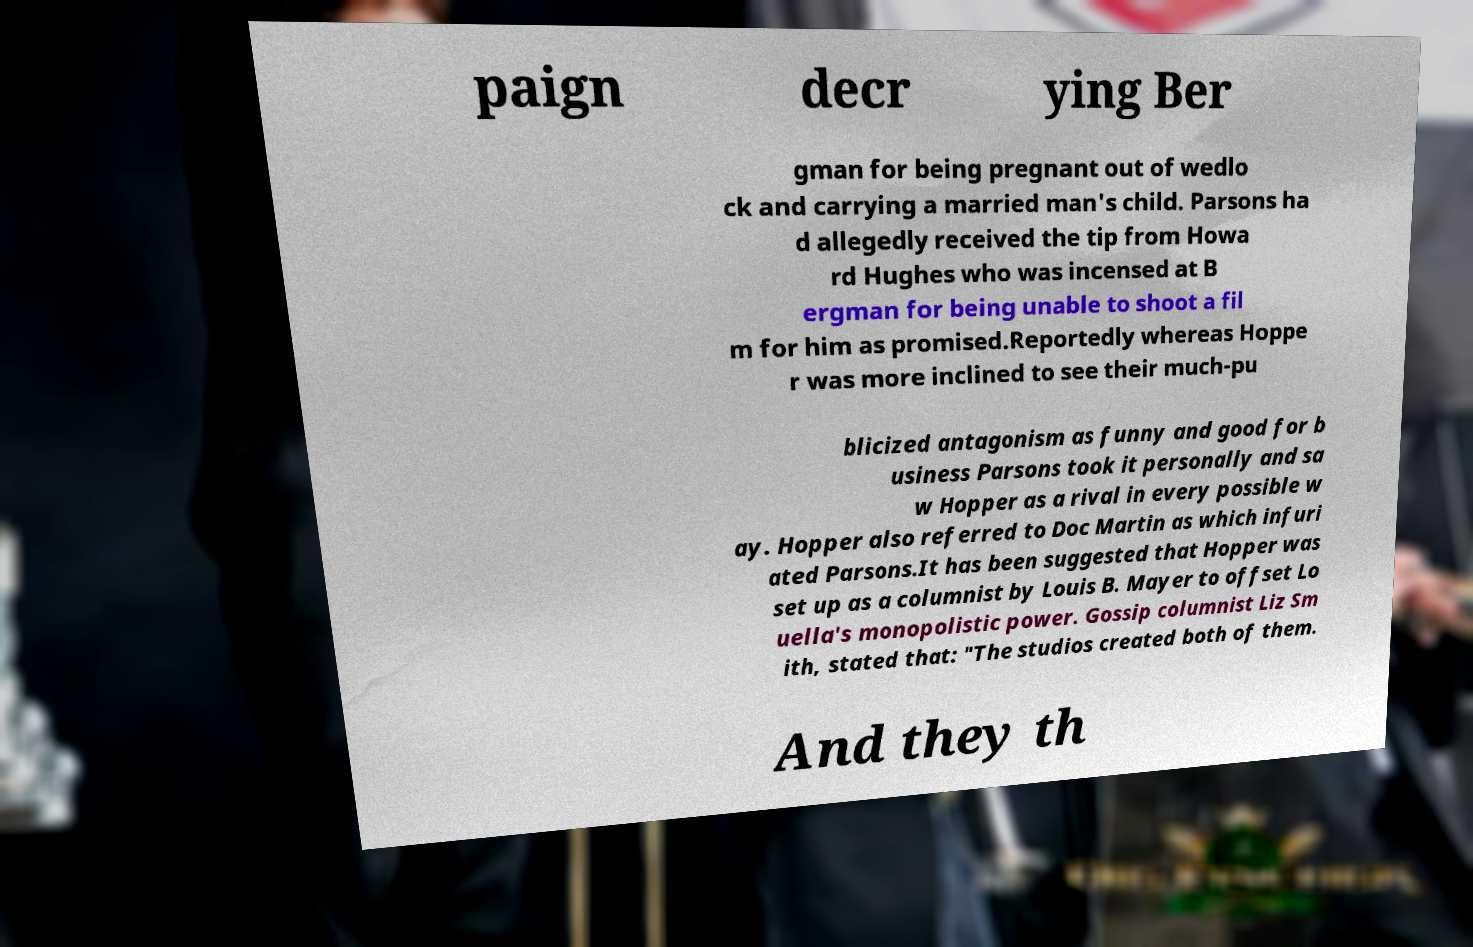What messages or text are displayed in this image? I need them in a readable, typed format. paign decr ying Ber gman for being pregnant out of wedlo ck and carrying a married man's child. Parsons ha d allegedly received the tip from Howa rd Hughes who was incensed at B ergman for being unable to shoot a fil m for him as promised.Reportedly whereas Hoppe r was more inclined to see their much-pu blicized antagonism as funny and good for b usiness Parsons took it personally and sa w Hopper as a rival in every possible w ay. Hopper also referred to Doc Martin as which infuri ated Parsons.It has been suggested that Hopper was set up as a columnist by Louis B. Mayer to offset Lo uella's monopolistic power. Gossip columnist Liz Sm ith, stated that: "The studios created both of them. And they th 